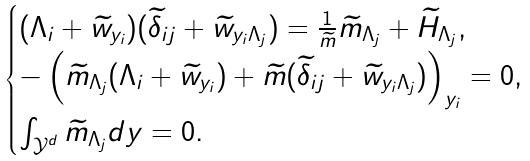Convert formula to latex. <formula><loc_0><loc_0><loc_500><loc_500>\begin{cases} ( \Lambda _ { i } + \widetilde { w } _ { y _ { i } } ) ( \widetilde { \delta } _ { i j } + \widetilde { w } _ { y _ { i } \Lambda _ { j } } ) = \frac { 1 } { \widetilde { m } } \widetilde { m } _ { \Lambda _ { j } } + \widetilde { H } _ { \Lambda _ { j } } , \\ - \left ( \widetilde { m } _ { \Lambda _ { j } } ( \Lambda _ { i } + \widetilde { w } _ { y _ { i } } ) + \widetilde { m } ( \widetilde { \delta } _ { i j } + \widetilde { w } _ { y _ { i } \Lambda _ { j } } ) \right ) _ { y _ { i } } = 0 , \\ \int _ { \mathcal { Y } ^ { d } } \widetilde { m } _ { \Lambda _ { j } } d y = 0 . \end{cases}</formula> 